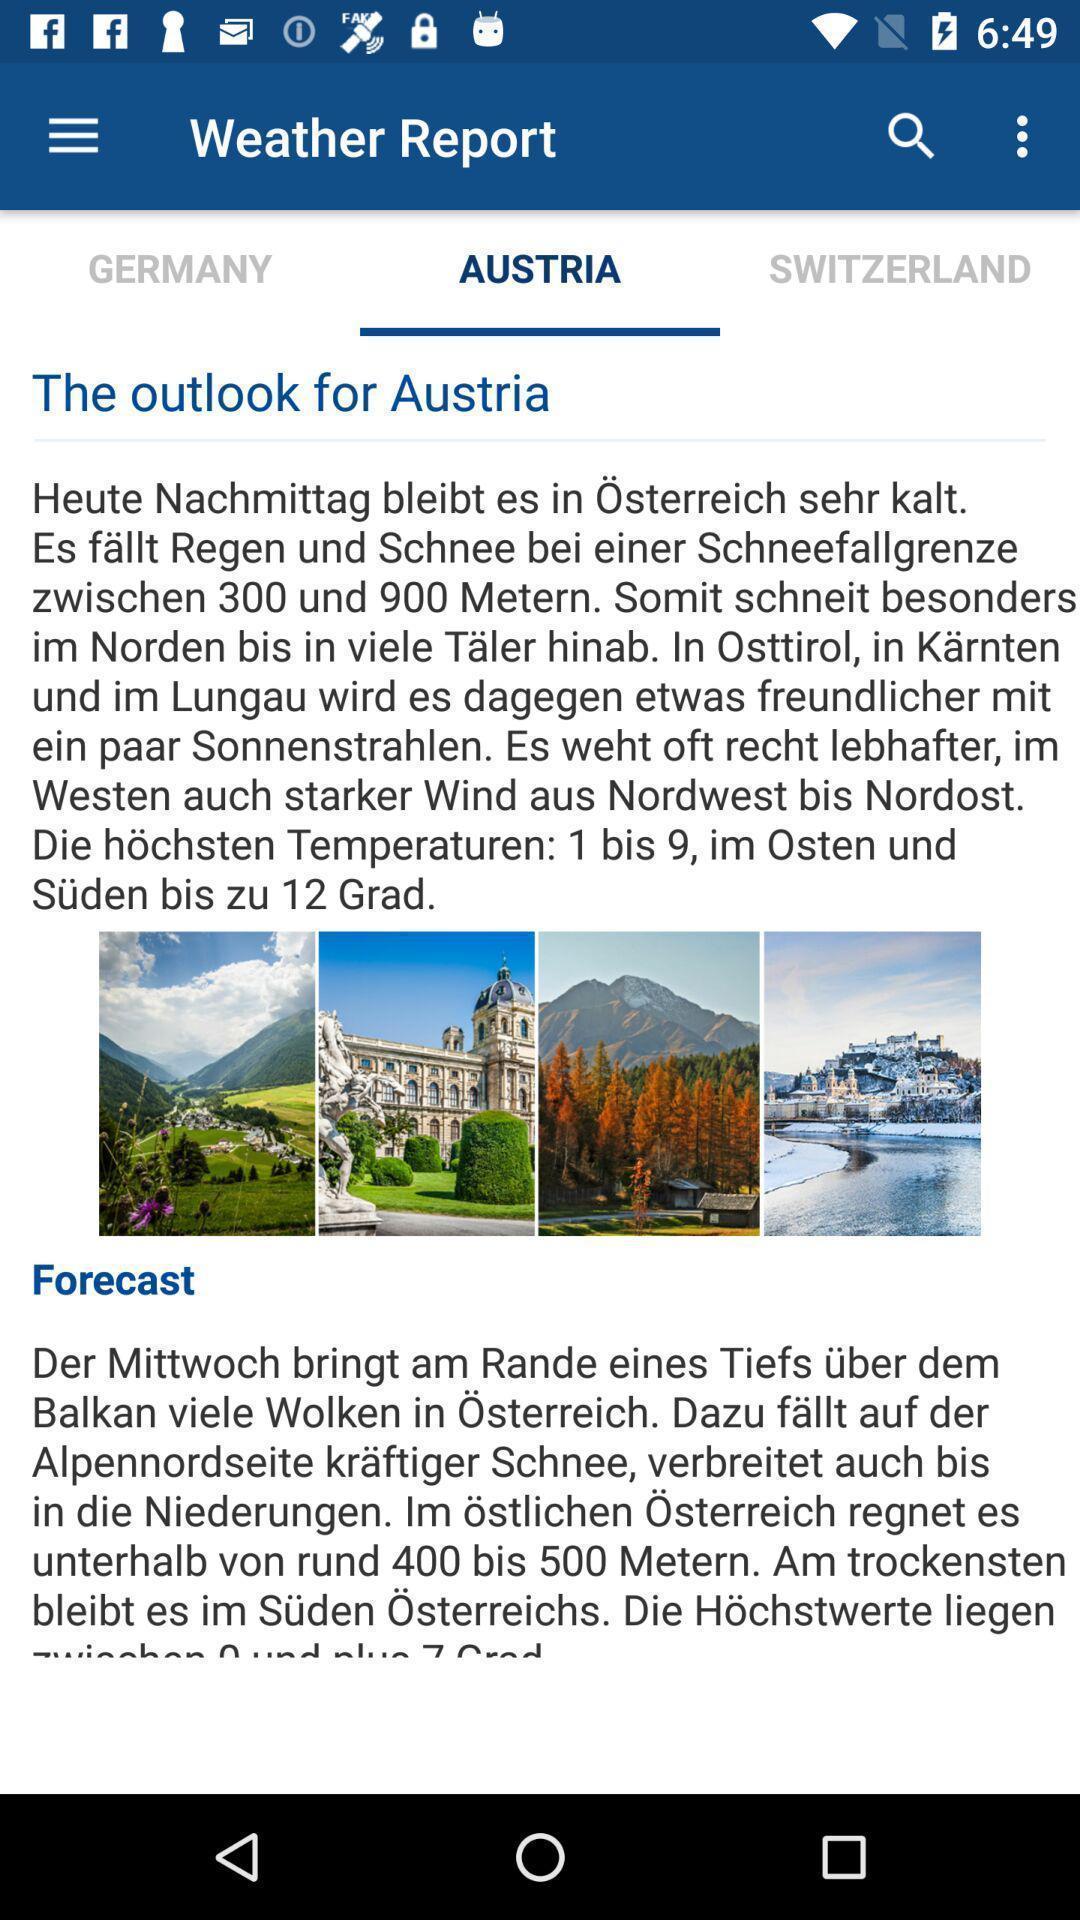Summarize the information in this screenshot. Weather report page displaying in application. 